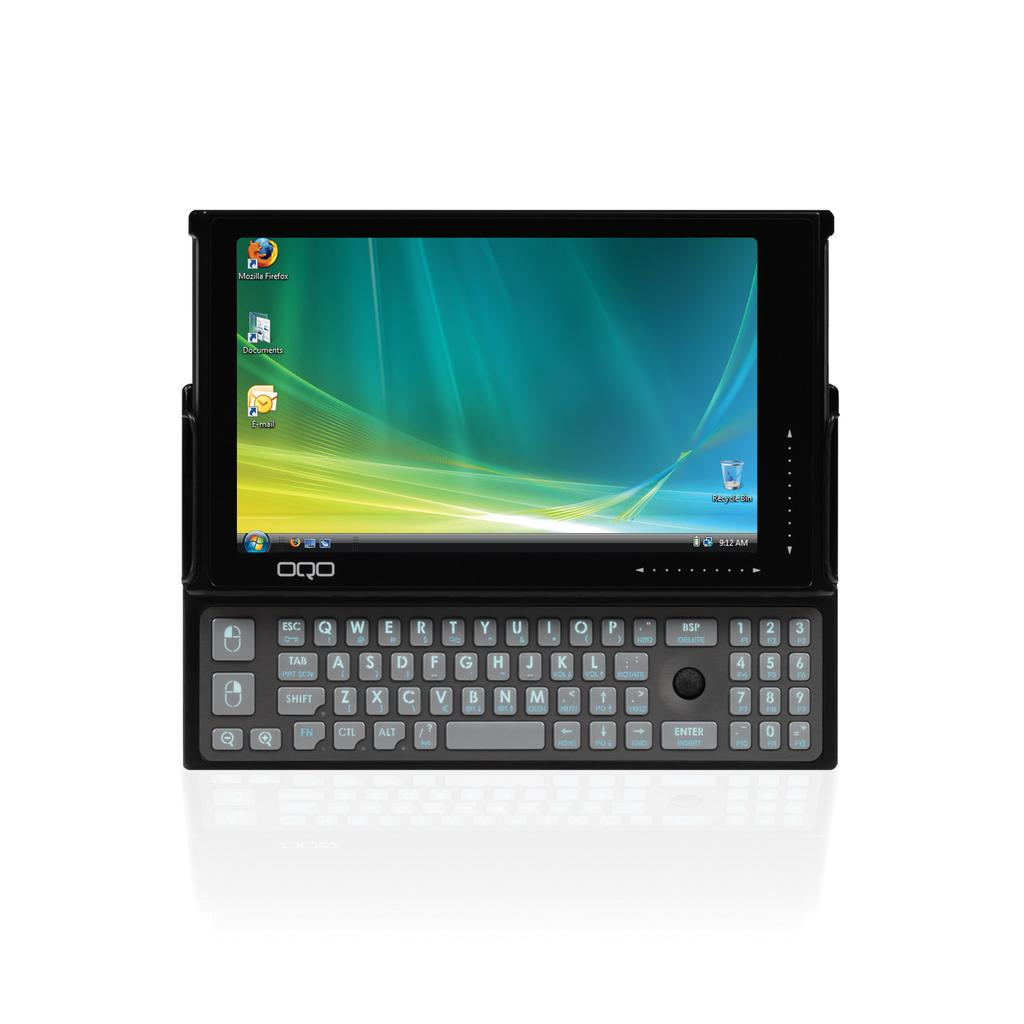<image>
Summarize the visual content of the image. A tablet attached to a keyboard with Mozilla Firefox browser installed. 